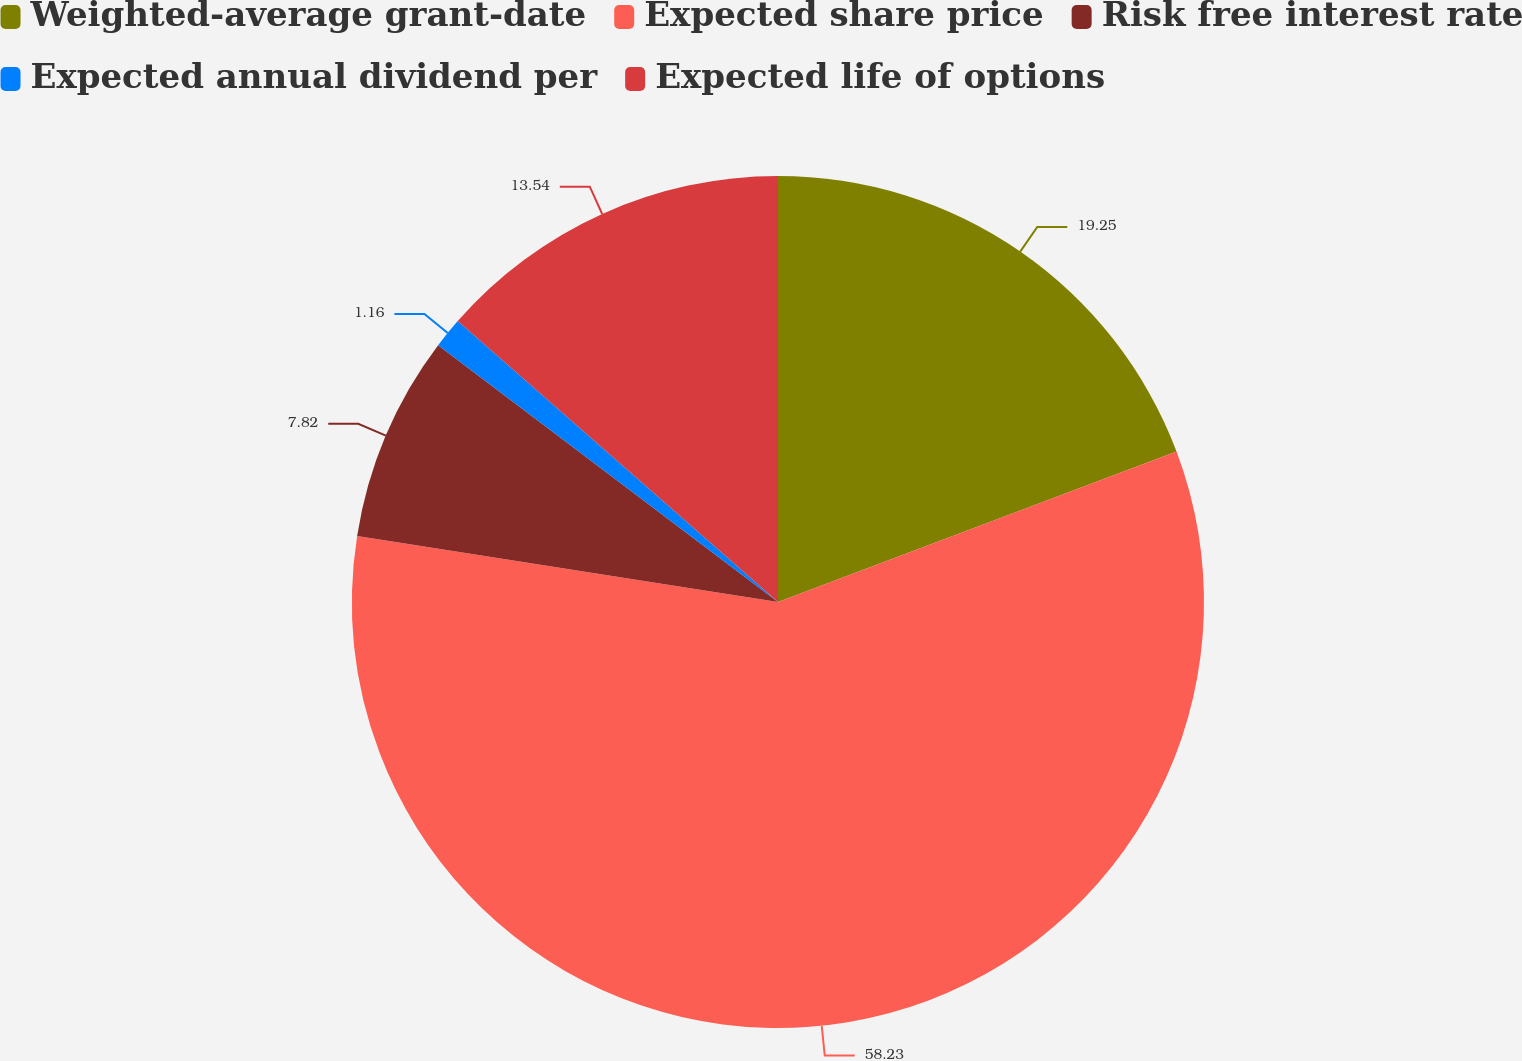Convert chart. <chart><loc_0><loc_0><loc_500><loc_500><pie_chart><fcel>Weighted-average grant-date<fcel>Expected share price<fcel>Risk free interest rate<fcel>Expected annual dividend per<fcel>Expected life of options<nl><fcel>19.25%<fcel>58.22%<fcel>7.82%<fcel>1.16%<fcel>13.54%<nl></chart> 